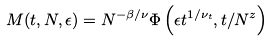<formula> <loc_0><loc_0><loc_500><loc_500>M ( t , N , \epsilon ) = N ^ { - \beta / \nu } \Phi \left ( \epsilon t ^ { 1 / \nu _ { t } } , t / N ^ { z } \right )</formula> 